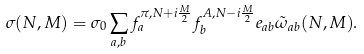<formula> <loc_0><loc_0><loc_500><loc_500>\sigma ( N , M ) = \sigma _ { 0 } \sum _ { a , b } f _ { a } ^ { \pi , N + i \frac { M } { 2 } } f _ { b } ^ { A , N - i \frac { M } { 2 } } e _ { a b } \tilde { \omega } _ { a b } ( N , M ) .</formula> 